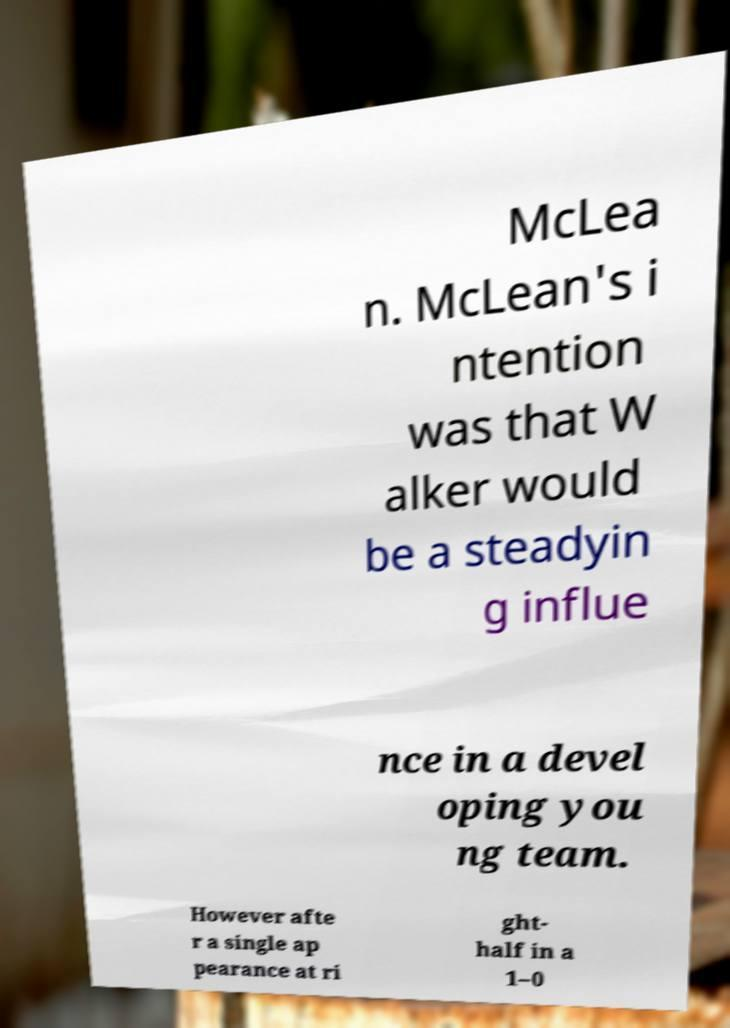Could you extract and type out the text from this image? McLea n. McLean's i ntention was that W alker would be a steadyin g influe nce in a devel oping you ng team. However afte r a single ap pearance at ri ght- half in a 1–0 